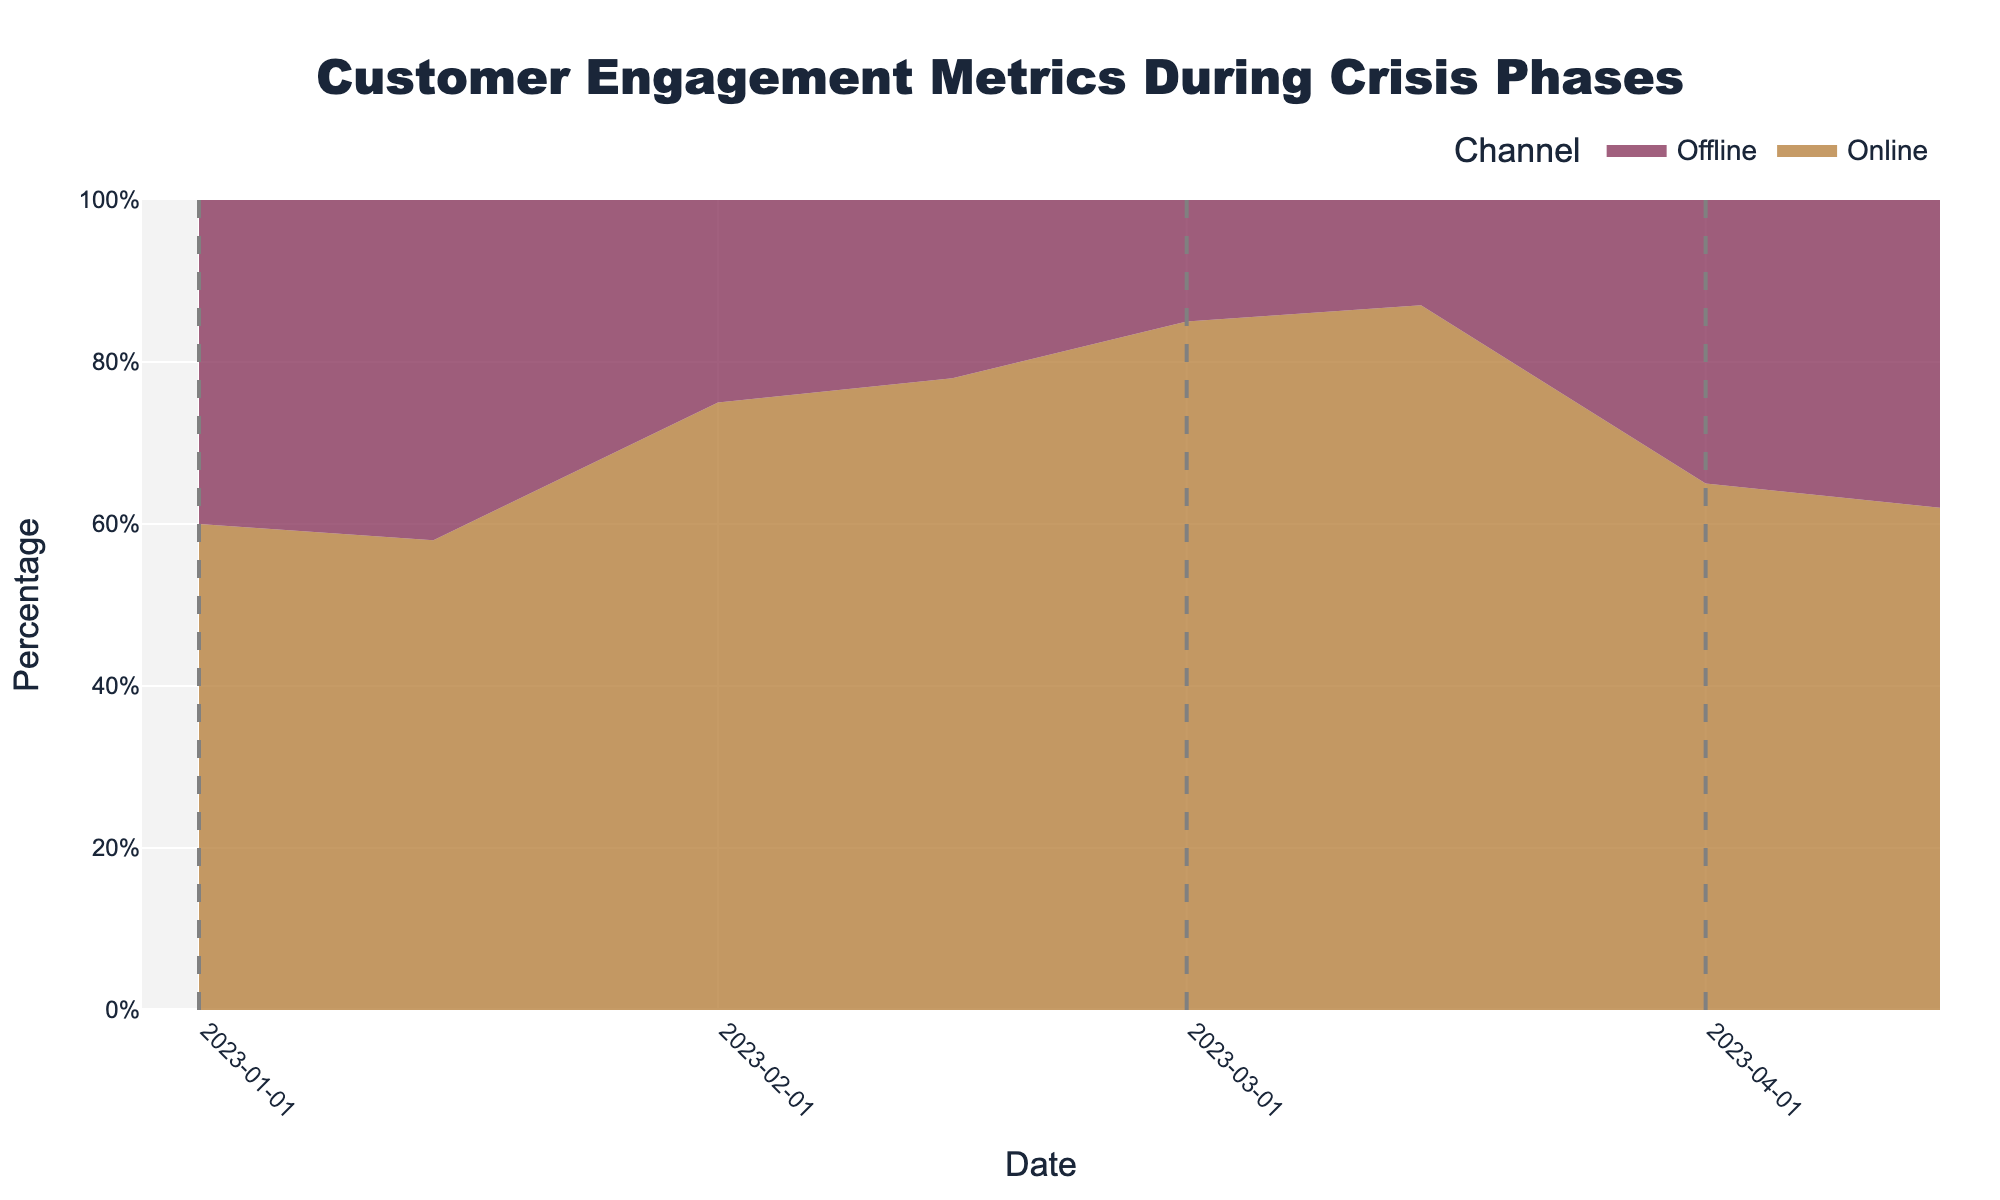what is the title of the chart? The title of the chart is displayed at the top of the figure. It provides a summary of the chart's content.
Answer: Customer Engagement Metrics During Crisis Phases Which phase shows the highest percentage of online engagement? To answer this, look at the different phases in the chart and identify the one where the online engagement (the specified area for Online) reaches its peak value.
Answer: Crisis-Peak How do online and offline engagement percentages compare on 2023-02-01? Check for the date 2023-02-01 in the chart and analyze the values for both online and offline channels.
Answer: Online: 75%, Offline: 25% What can be inferred about customer engagement trends moving from Pre-Crisis to Crisis-Peak? Observe the trend lines for both online and offline channels from Pre-Crisis to Crisis-Peak. Online engagement increases while offline engagement decreases.
Answer: Online engagement increases, offline engagement decreases Is there any phase where offline engagement is greater than 40%? Look at each phase and check the percentage areas for the offline channel to see which ones cross the 40% mark.
Answer: No Compare the percentage change from Crisis-Begin to Post-Crisis for online engagement. Compare the percentage values for the online channel at the start of Crisis-Begin and the end of Post-Crisis phases. The change is (65-75) or (62-78) depending on the dates considered within the phases.
Answer: Decrease of 10-16% During which phase do we see the most balanced engagement between online and offline channels? Look for the phase where the percentages of both channels are closest to each other, meaning the least disparity.
Answer: Pre-Crisis What is the trend of offline engagement from Crisis-Peak to Post-Crisis? Examine how the offline engagement area changes as it moves from Crisis-Peak to Post-Crisis. Notice whether it increases, decreases, or stays constant.
Answer: Increases How does the engagement distribution change immediately after the crisis peaks? Focus on the transition from Crisis-Peak to Post-Crisis and observe the changes in the relative areas representing online and offline engagements.
Answer: Online engagement decreases, offline engagement increases 